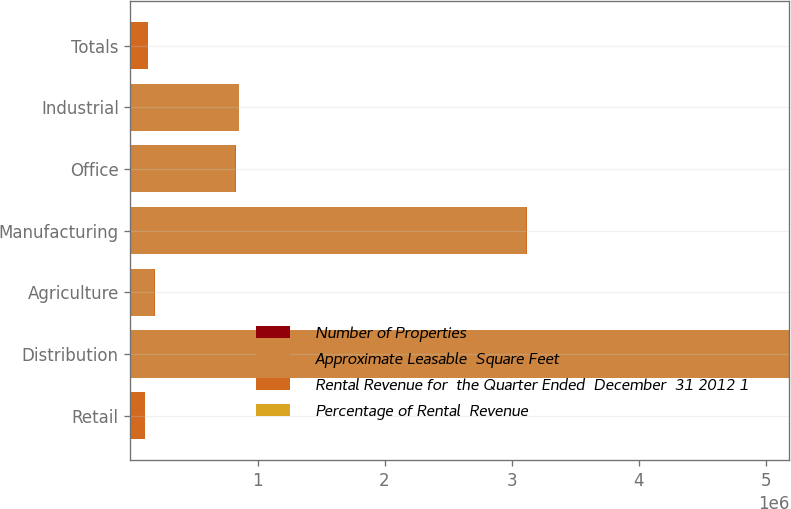Convert chart. <chart><loc_0><loc_0><loc_500><loc_500><stacked_bar_chart><ecel><fcel>Retail<fcel>Distribution<fcel>Agriculture<fcel>Manufacturing<fcel>Office<fcel>Industrial<fcel>Totals<nl><fcel>Number of Properties<fcel>2941<fcel>23<fcel>15<fcel>10<fcel>9<fcel>15<fcel>3013<nl><fcel>Approximate Leasable  Square Feet<fcel>2255.5<fcel>5.1812e+06<fcel>184500<fcel>3.1171e+06<fcel>824000<fcel>850500<fcel>2255.5<nl><fcel>Rental Revenue for  the Quarter Ended  December  31 2012 1<fcel>111218<fcel>6131<fcel>5138<fcel>3775<fcel>3110<fcel>1570<fcel>130942<nl><fcel>Percentage of Rental  Revenue<fcel>84.9<fcel>4.7<fcel>3.9<fcel>2.9<fcel>2.4<fcel>1.2<fcel>100<nl></chart> 